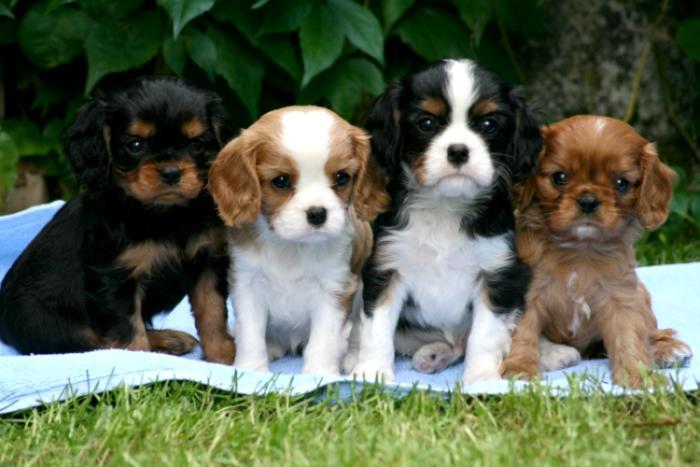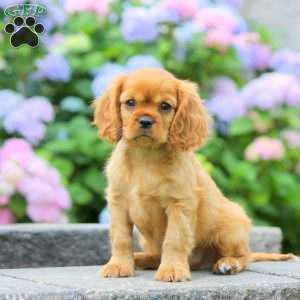The first image is the image on the left, the second image is the image on the right. Given the left and right images, does the statement "There are no more than two puppies." hold true? Answer yes or no. No. The first image is the image on the left, the second image is the image on the right. For the images displayed, is the sentence "One of the puppies is wearing a collar with pink heart." factually correct? Answer yes or no. No. The first image is the image on the left, the second image is the image on the right. Considering the images on both sides, is "There are atleast 4 cute dogs total" valid? Answer yes or no. Yes. The first image is the image on the left, the second image is the image on the right. Analyze the images presented: Is the assertion "There are at most two dogs." valid? Answer yes or no. No. 